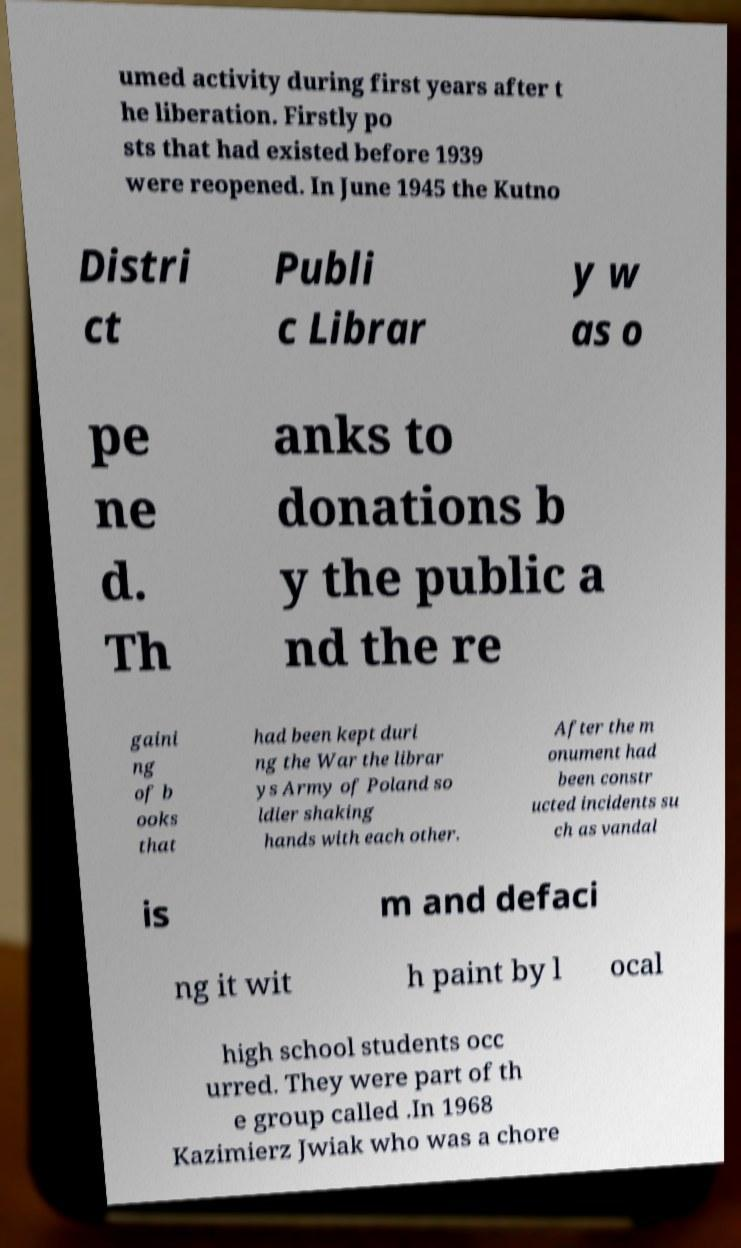Can you accurately transcribe the text from the provided image for me? umed activity during first years after t he liberation. Firstly po sts that had existed before 1939 were reopened. In June 1945 the Kutno Distri ct Publi c Librar y w as o pe ne d. Th anks to donations b y the public a nd the re gaini ng of b ooks that had been kept duri ng the War the librar ys Army of Poland so ldier shaking hands with each other. After the m onument had been constr ucted incidents su ch as vandal is m and defaci ng it wit h paint by l ocal high school students occ urred. They were part of th e group called .In 1968 Kazimierz Jwiak who was a chore 